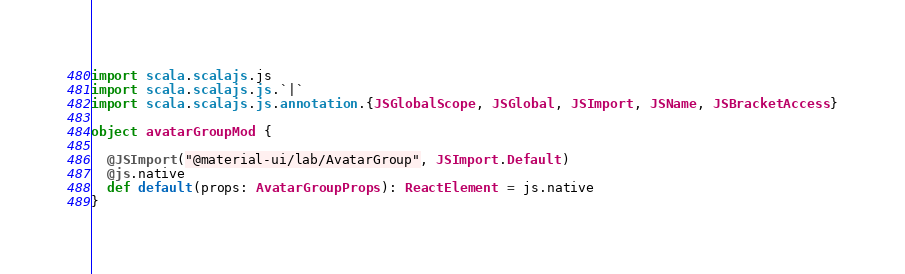Convert code to text. <code><loc_0><loc_0><loc_500><loc_500><_Scala_>import scala.scalajs.js
import scala.scalajs.js.`|`
import scala.scalajs.js.annotation.{JSGlobalScope, JSGlobal, JSImport, JSName, JSBracketAccess}

object avatarGroupMod {
  
  @JSImport("@material-ui/lab/AvatarGroup", JSImport.Default)
  @js.native
  def default(props: AvatarGroupProps): ReactElement = js.native
}
</code> 